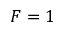<formula> <loc_0><loc_0><loc_500><loc_500>F = 1</formula> 